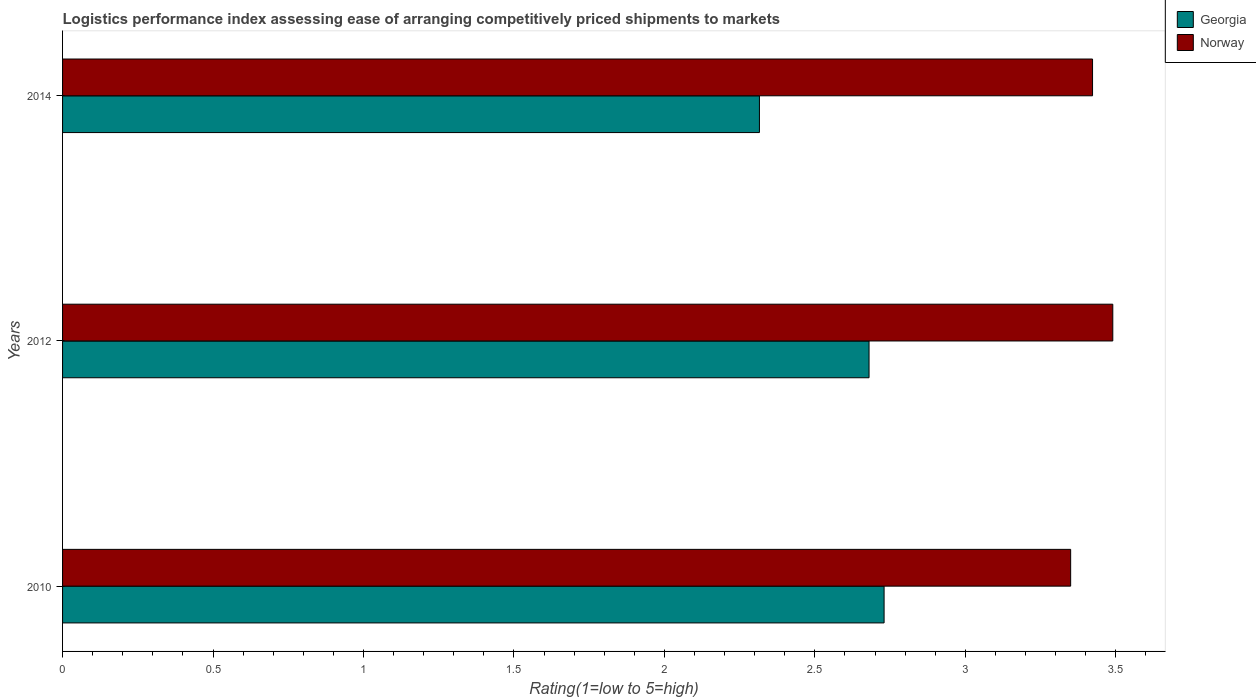How many bars are there on the 2nd tick from the top?
Keep it short and to the point. 2. How many bars are there on the 1st tick from the bottom?
Give a very brief answer. 2. In how many cases, is the number of bars for a given year not equal to the number of legend labels?
Ensure brevity in your answer.  0. What is the Logistic performance index in Georgia in 2014?
Your answer should be very brief. 2.32. Across all years, what is the maximum Logistic performance index in Georgia?
Provide a succinct answer. 2.73. Across all years, what is the minimum Logistic performance index in Georgia?
Provide a short and direct response. 2.32. In which year was the Logistic performance index in Georgia maximum?
Provide a succinct answer. 2010. In which year was the Logistic performance index in Georgia minimum?
Your response must be concise. 2014. What is the total Logistic performance index in Norway in the graph?
Keep it short and to the point. 10.26. What is the difference between the Logistic performance index in Norway in 2010 and that in 2012?
Make the answer very short. -0.14. What is the difference between the Logistic performance index in Norway in 2010 and the Logistic performance index in Georgia in 2012?
Your response must be concise. 0.67. What is the average Logistic performance index in Georgia per year?
Keep it short and to the point. 2.58. In the year 2012, what is the difference between the Logistic performance index in Georgia and Logistic performance index in Norway?
Your answer should be compact. -0.81. What is the ratio of the Logistic performance index in Georgia in 2010 to that in 2012?
Provide a succinct answer. 1.02. Is the Logistic performance index in Norway in 2010 less than that in 2012?
Your response must be concise. Yes. What is the difference between the highest and the second highest Logistic performance index in Georgia?
Provide a short and direct response. 0.05. What is the difference between the highest and the lowest Logistic performance index in Norway?
Ensure brevity in your answer.  0.14. Is the sum of the Logistic performance index in Norway in 2010 and 2014 greater than the maximum Logistic performance index in Georgia across all years?
Your response must be concise. Yes. What does the 2nd bar from the top in 2014 represents?
Make the answer very short. Georgia. How many bars are there?
Make the answer very short. 6. Are all the bars in the graph horizontal?
Your answer should be very brief. Yes. How are the legend labels stacked?
Your response must be concise. Vertical. What is the title of the graph?
Your answer should be very brief. Logistics performance index assessing ease of arranging competitively priced shipments to markets. What is the label or title of the X-axis?
Ensure brevity in your answer.  Rating(1=low to 5=high). What is the Rating(1=low to 5=high) in Georgia in 2010?
Make the answer very short. 2.73. What is the Rating(1=low to 5=high) in Norway in 2010?
Ensure brevity in your answer.  3.35. What is the Rating(1=low to 5=high) in Georgia in 2012?
Offer a terse response. 2.68. What is the Rating(1=low to 5=high) in Norway in 2012?
Make the answer very short. 3.49. What is the Rating(1=low to 5=high) of Georgia in 2014?
Keep it short and to the point. 2.32. What is the Rating(1=low to 5=high) in Norway in 2014?
Offer a terse response. 3.42. Across all years, what is the maximum Rating(1=low to 5=high) in Georgia?
Your answer should be compact. 2.73. Across all years, what is the maximum Rating(1=low to 5=high) of Norway?
Provide a succinct answer. 3.49. Across all years, what is the minimum Rating(1=low to 5=high) of Georgia?
Keep it short and to the point. 2.32. Across all years, what is the minimum Rating(1=low to 5=high) of Norway?
Provide a succinct answer. 3.35. What is the total Rating(1=low to 5=high) of Georgia in the graph?
Offer a very short reply. 7.73. What is the total Rating(1=low to 5=high) in Norway in the graph?
Your response must be concise. 10.26. What is the difference between the Rating(1=low to 5=high) in Georgia in 2010 and that in 2012?
Provide a short and direct response. 0.05. What is the difference between the Rating(1=low to 5=high) of Norway in 2010 and that in 2012?
Offer a very short reply. -0.14. What is the difference between the Rating(1=low to 5=high) of Georgia in 2010 and that in 2014?
Your answer should be very brief. 0.41. What is the difference between the Rating(1=low to 5=high) of Norway in 2010 and that in 2014?
Provide a short and direct response. -0.07. What is the difference between the Rating(1=low to 5=high) of Georgia in 2012 and that in 2014?
Offer a terse response. 0.36. What is the difference between the Rating(1=low to 5=high) of Norway in 2012 and that in 2014?
Give a very brief answer. 0.07. What is the difference between the Rating(1=low to 5=high) of Georgia in 2010 and the Rating(1=low to 5=high) of Norway in 2012?
Your answer should be very brief. -0.76. What is the difference between the Rating(1=low to 5=high) of Georgia in 2010 and the Rating(1=low to 5=high) of Norway in 2014?
Your answer should be compact. -0.69. What is the difference between the Rating(1=low to 5=high) of Georgia in 2012 and the Rating(1=low to 5=high) of Norway in 2014?
Keep it short and to the point. -0.74. What is the average Rating(1=low to 5=high) of Georgia per year?
Provide a short and direct response. 2.58. What is the average Rating(1=low to 5=high) in Norway per year?
Your answer should be very brief. 3.42. In the year 2010, what is the difference between the Rating(1=low to 5=high) of Georgia and Rating(1=low to 5=high) of Norway?
Your answer should be very brief. -0.62. In the year 2012, what is the difference between the Rating(1=low to 5=high) of Georgia and Rating(1=low to 5=high) of Norway?
Your answer should be compact. -0.81. In the year 2014, what is the difference between the Rating(1=low to 5=high) in Georgia and Rating(1=low to 5=high) in Norway?
Your answer should be very brief. -1.11. What is the ratio of the Rating(1=low to 5=high) of Georgia in 2010 to that in 2012?
Your answer should be compact. 1.02. What is the ratio of the Rating(1=low to 5=high) in Norway in 2010 to that in 2012?
Offer a very short reply. 0.96. What is the ratio of the Rating(1=low to 5=high) in Georgia in 2010 to that in 2014?
Provide a short and direct response. 1.18. What is the ratio of the Rating(1=low to 5=high) of Norway in 2010 to that in 2014?
Offer a terse response. 0.98. What is the ratio of the Rating(1=low to 5=high) of Georgia in 2012 to that in 2014?
Provide a succinct answer. 1.16. What is the ratio of the Rating(1=low to 5=high) of Norway in 2012 to that in 2014?
Offer a terse response. 1.02. What is the difference between the highest and the second highest Rating(1=low to 5=high) in Norway?
Offer a terse response. 0.07. What is the difference between the highest and the lowest Rating(1=low to 5=high) of Georgia?
Offer a terse response. 0.41. What is the difference between the highest and the lowest Rating(1=low to 5=high) of Norway?
Offer a terse response. 0.14. 